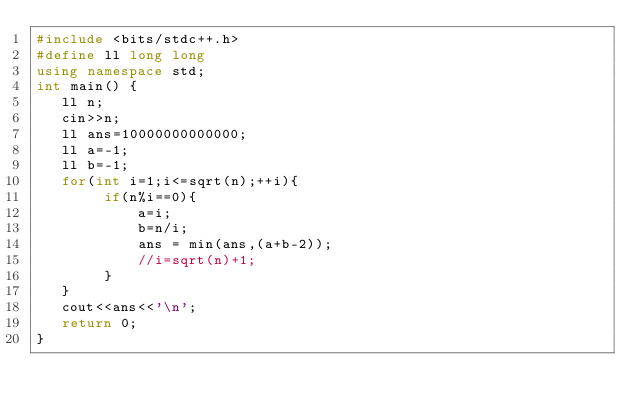<code> <loc_0><loc_0><loc_500><loc_500><_C++_>#include <bits/stdc++.h>
#define ll long long
using namespace std;
int main() {
   ll n;
   cin>>n;
   ll ans=10000000000000;
   ll a=-1;
   ll b=-1;
   for(int i=1;i<=sqrt(n);++i){
        if(n%i==0){
            a=i;
            b=n/i;
            ans = min(ans,(a+b-2));
            //i=sqrt(n)+1;
        }
   }
   cout<<ans<<'\n';
   return 0;
}
</code> 